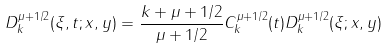Convert formula to latex. <formula><loc_0><loc_0><loc_500><loc_500>D _ { k } ^ { \mu + 1 / 2 } ( \xi , t ; x , y ) = \frac { k + \mu + 1 / 2 } { \mu + 1 / 2 } C _ { k } ^ { \mu + 1 / 2 } ( t ) D _ { k } ^ { \mu + 1 / 2 } ( \xi ; x , y )</formula> 